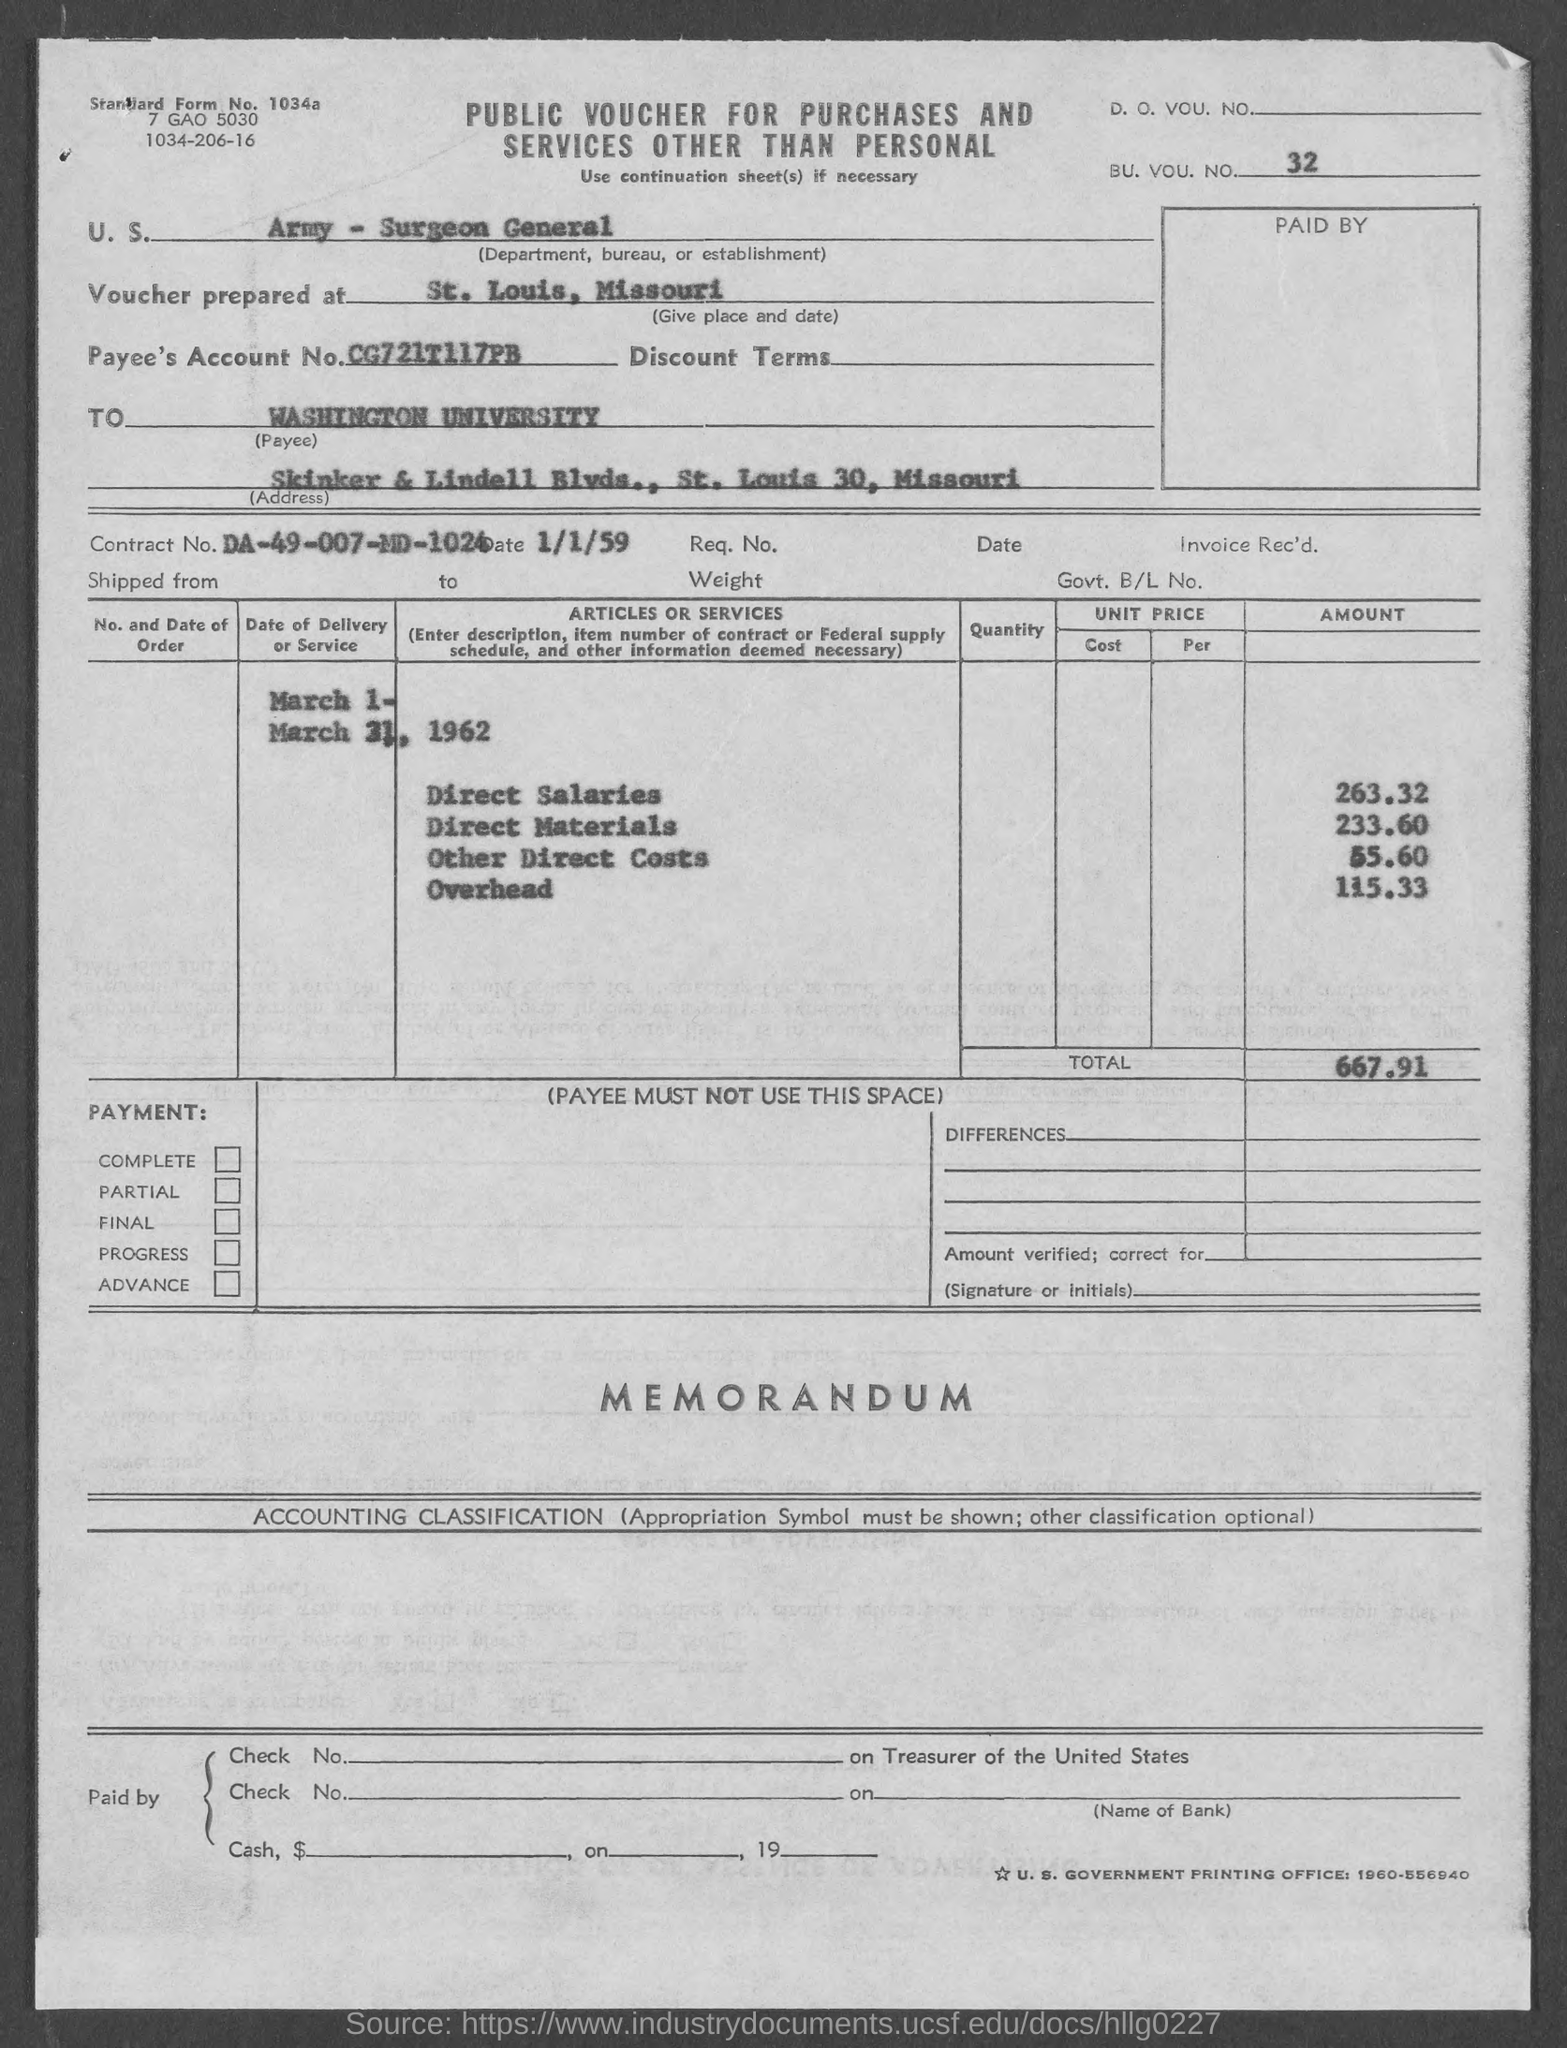What is the document title?
Your response must be concise. PUBLIC VOUCHER FOR PURCHASES AND SERVICES OTHER THAN PERSONAL. What is the standard form no.?
Provide a succinct answer. 1034a. What is the BU. VOU. NO. mentioned?
Offer a very short reply. 32. Which department, bureau or establishment is mentioned?
Keep it short and to the point. Army - Surgeon General. Where was the voucher prepared at?
Offer a terse response. St. Louis, Missouri. What is Payee's Account No.?
Offer a terse response. CG721T117PB. Who is the payee?
Make the answer very short. Washington University. What is the total amount?
Your answer should be very brief. 667.91. What is the Contract No.?
Offer a very short reply. DA-49-007-MD-1024. 